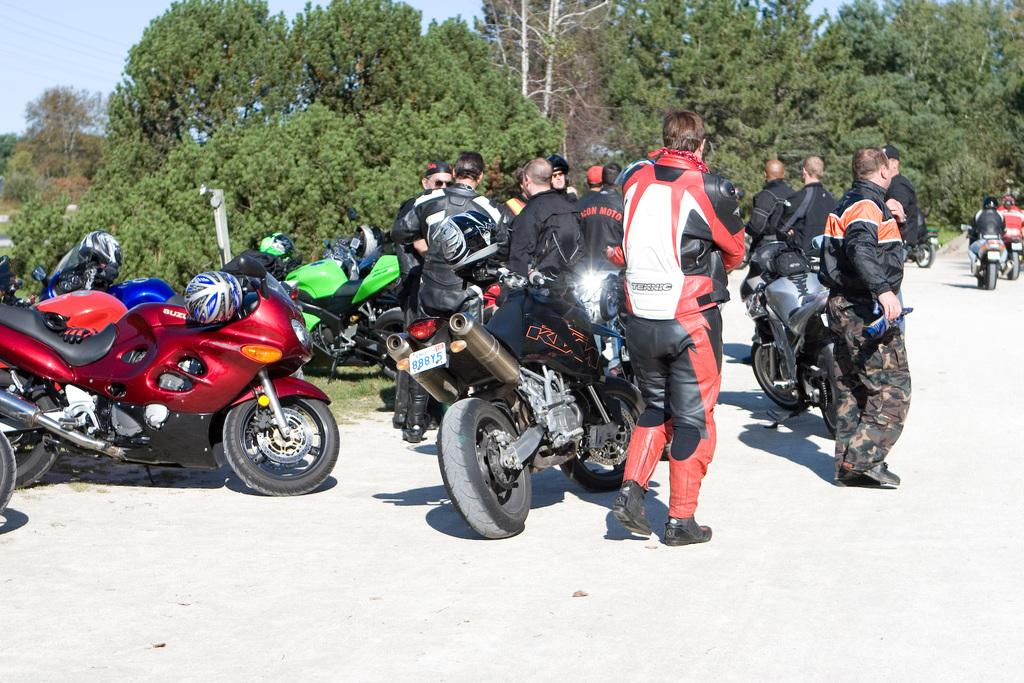What are the people in the image doing? The persons in the image are standing on the road. What else can be seen near the persons? Motor vehicles are present beside the persons. What can be seen in the background of the image? There are trees and the sky visible in the background of the image. What type of doctor can be seen treating a zebra in the image? There is no doctor or zebra present in the image. Can you tell me where the vase is located in the image? There is no vase present in the image. 